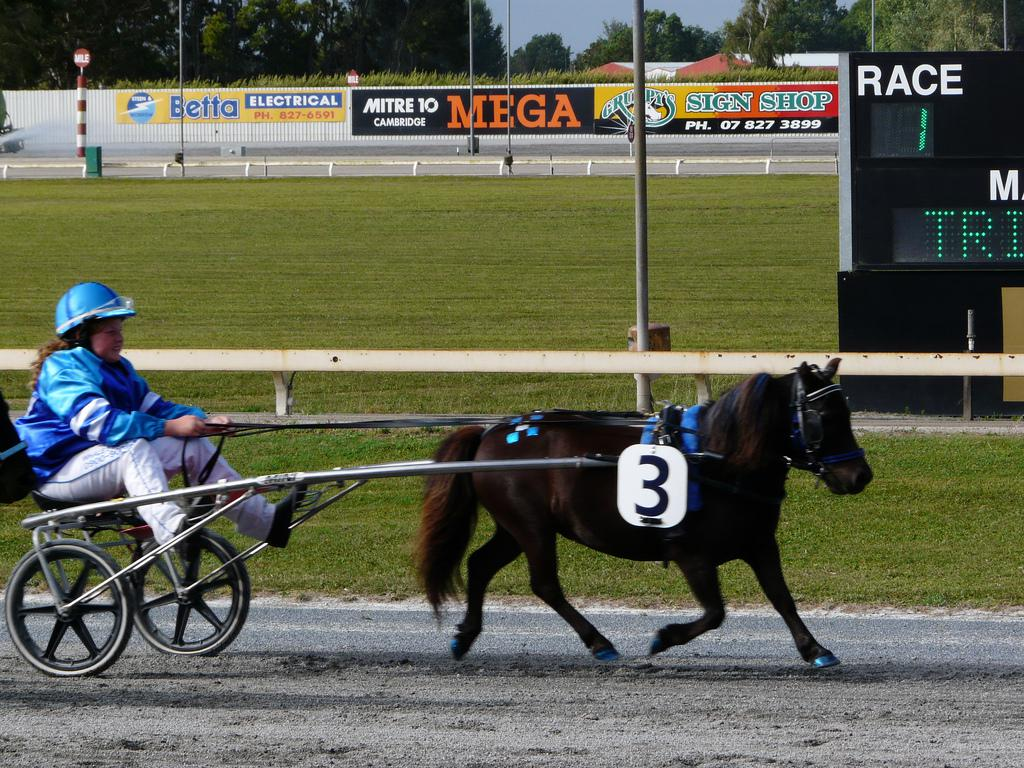Question: what is hanging on the wall?
Choices:
A. Pictures.
B. A painting.
C. A flag.
D. Several banners.
Answer with the letter. Answer: D Question: why is the woman behind a pony?
Choices:
A. She is showing it.
B. She is about to ride it.
C. She is petting the pony.
D. She is racing.
Answer with the letter. Answer: D Question: what color is the ground?
Choices:
A. Brown.
B. Gray.
C. Black.
D. Reddish.
Answer with the letter. Answer: B Question: how many wheels are on the woman's buggy?
Choices:
A. Two.
B. Four.
C. Six.
D. Eight.
Answer with the letter. Answer: A Question: who is racing the pony?
Choices:
A. A Dog.
B. A person.
C. A Cat.
D. A Monkey.
Answer with the letter. Answer: B Question: why is she sitting there?
Choices:
A. So she can read a book.
B. So she can take a rest.
C. So the horse can pull her.
D. So she can eat an apple.
Answer with the letter. Answer: C Question: what race is it?
Choices:
A. The second.
B. The third.
C. The last.
D. The first.
Answer with the letter. Answer: D Question: what number is on the pony?
Choices:
A. Three.
B. Two.
C. Fourty Four.
D. One.
Answer with the letter. Answer: A Question: what color is the paint on the hooves?
Choices:
A. Black.
B. Blue.
C. Yellow.
D. White.
Answer with the letter. Answer: B Question: where do you see the nose of another pony?
Choices:
A. In the middle of the picture.
B. Poking out of the water.
C. On the left side of the picture.
D. On the right side of the picture.
Answer with the letter. Answer: C Question: what does the phone number on the billboard indicates?
Choices:
A. The company is located in texas.
B. That the race is not in united states.
C. The number is toll free.
D. The event will be held in georgia.
Answer with the letter. Answer: B 